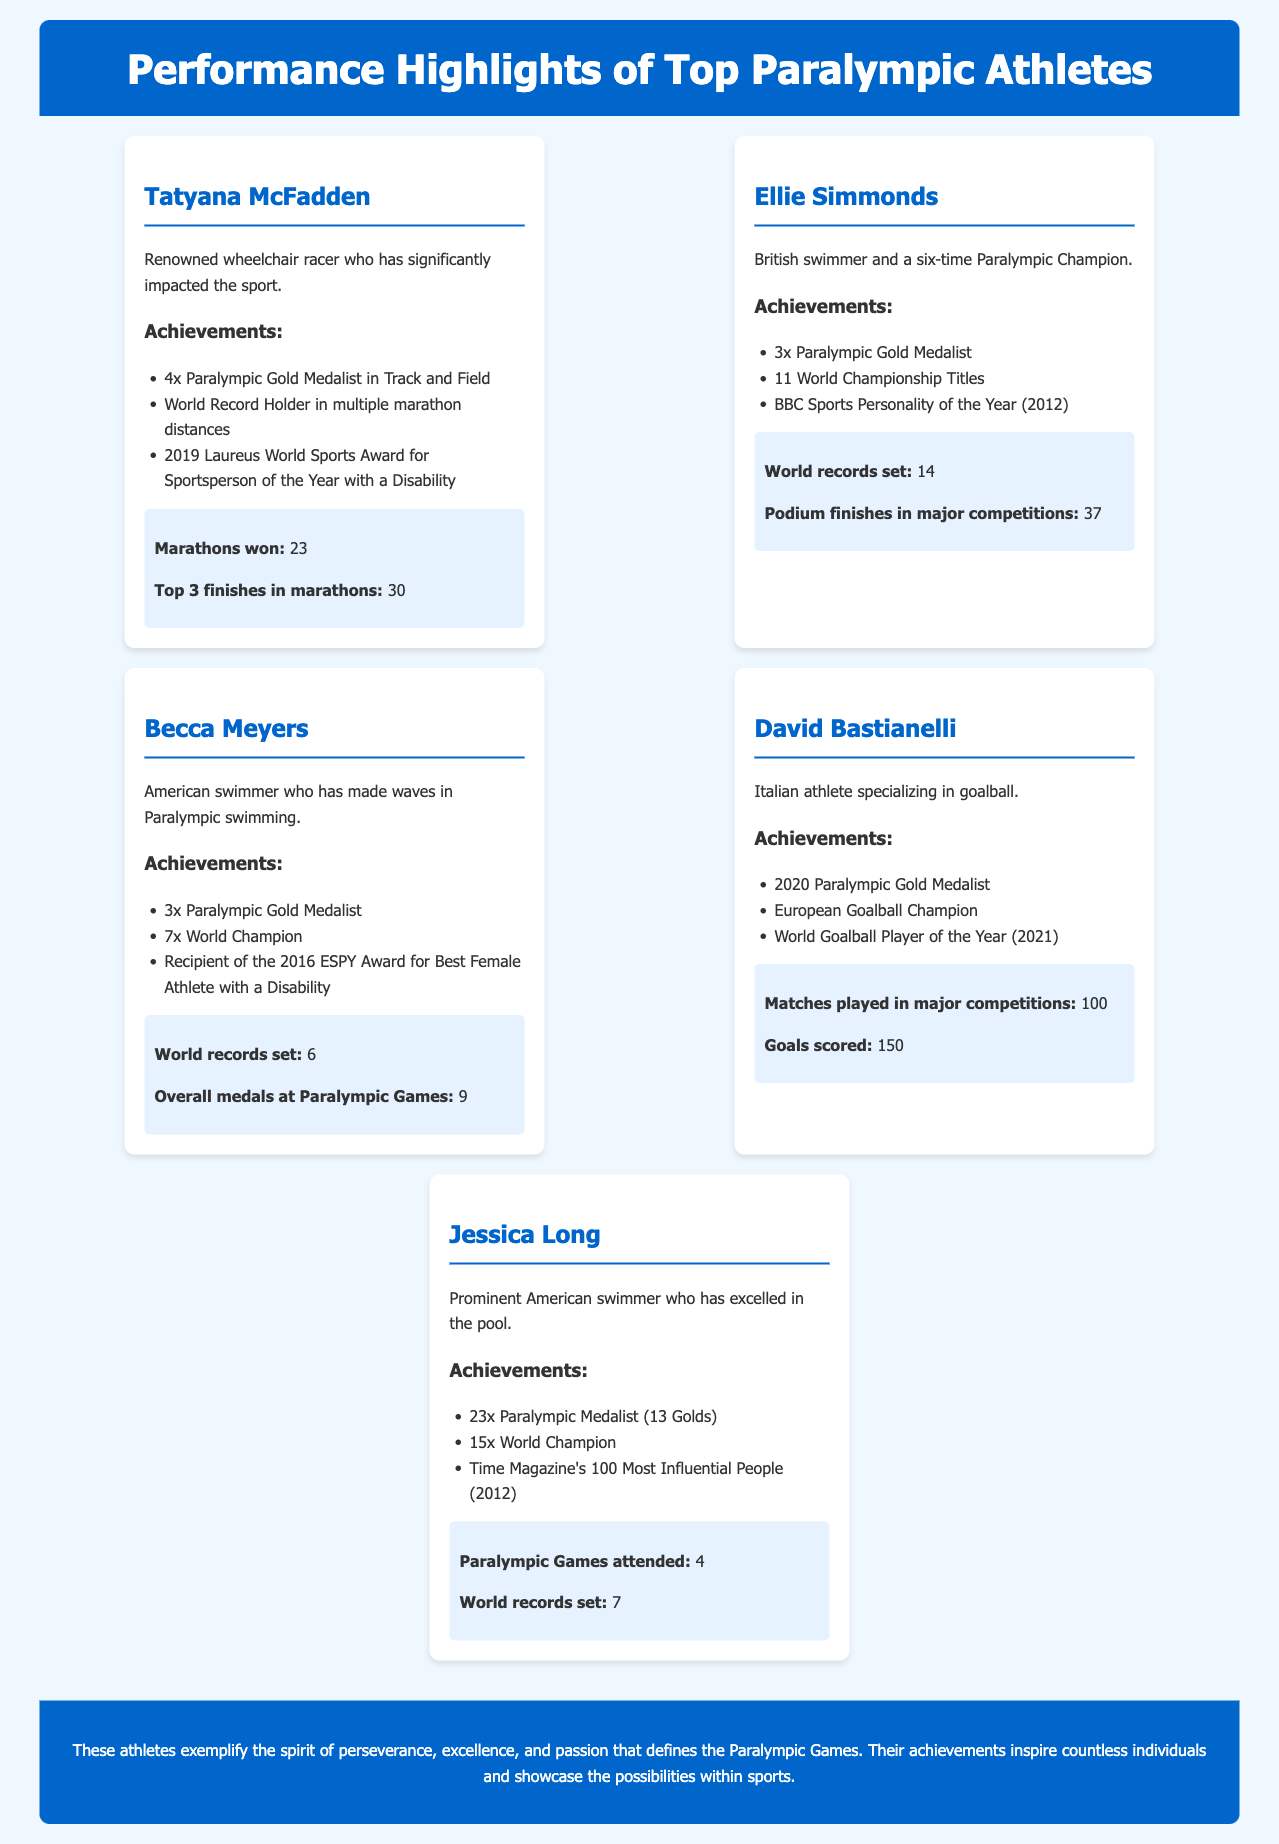What is Tatyana McFadden known for? Tatyana McFadden is renowned as a wheelchair racer who has significantly impacted the sport.
Answer: Wheelchair racer How many Paralympic Gold Medals has Ellie Simmonds won? Ellie Simmonds has won 3 Paralympic Gold Medals.
Answer: 3 What record did Becca Meyers set? Becca Meyers set 6 world records in Paralympic swimming.
Answer: 6 How many times has Jessica Long attended the Paralympic Games? Jessica Long has attended the Paralympic Games 4 times.
Answer: 4 What year was David Bastianelli the World Goalball Player of the Year? David Bastianelli was the World Goalball Player of the Year in 2021.
Answer: 2021 Which athlete has the highest number of overall medals at the Paralympic Games? Jessica Long has the highest number of overall medals at the Paralympic Games with 23.
Answer: 23 How many World Championship Titles does Ellie Simmonds have? Ellie Simmonds has 11 World Championship Titles.
Answer: 11 What is the main theme of the conclusion in the document? The conclusion emphasizes the spirit of perseverance, excellence, and passion that defines the Paralympic Games.
Answer: Perseverance What achievement is common among Tatyana McFadden, Becca Meyers, and Jessica Long? All three athletes are Paralympic Gold Medalists.
Answer: Paralympic Gold Medalists 